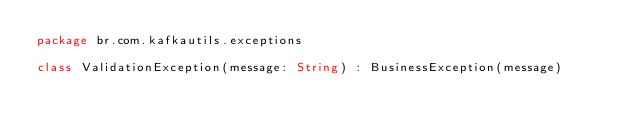Convert code to text. <code><loc_0><loc_0><loc_500><loc_500><_Kotlin_>package br.com.kafkautils.exceptions

class ValidationException(message: String) : BusinessException(message)
</code> 